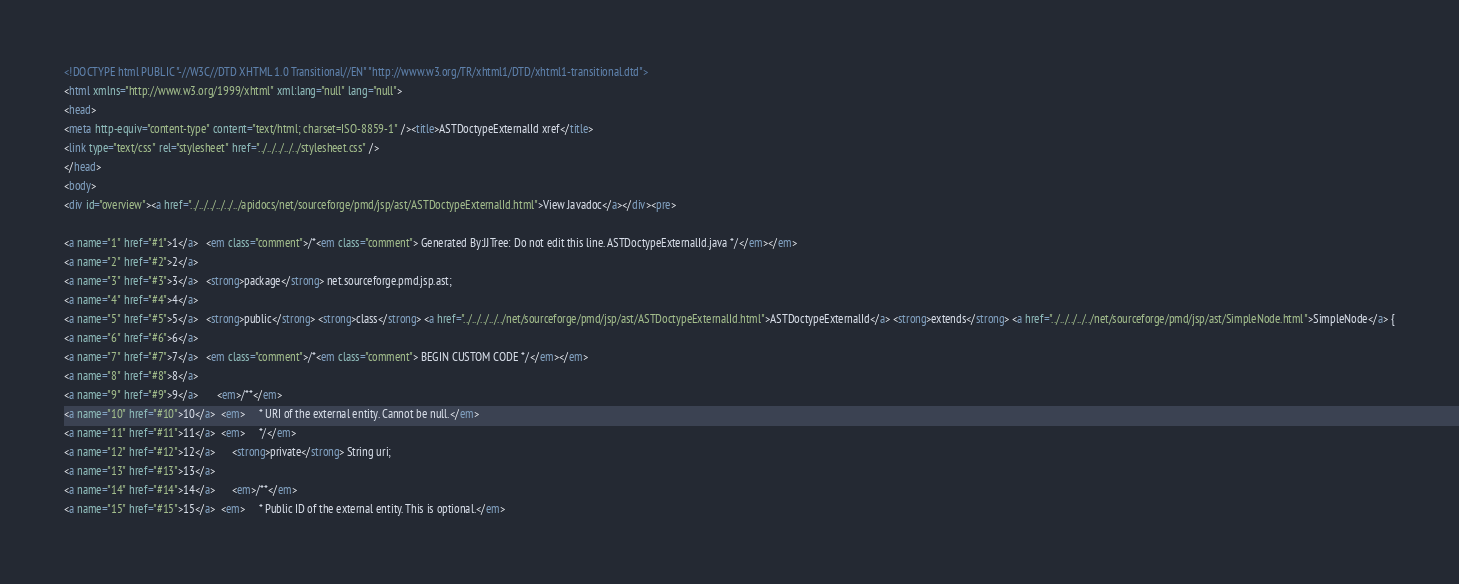<code> <loc_0><loc_0><loc_500><loc_500><_HTML_><!DOCTYPE html PUBLIC "-//W3C//DTD XHTML 1.0 Transitional//EN" "http://www.w3.org/TR/xhtml1/DTD/xhtml1-transitional.dtd">
<html xmlns="http://www.w3.org/1999/xhtml" xml:lang="null" lang="null">
<head>
<meta http-equiv="content-type" content="text/html; charset=ISO-8859-1" /><title>ASTDoctypeExternalId xref</title>
<link type="text/css" rel="stylesheet" href="../../../../../stylesheet.css" />
</head>
<body>
<div id="overview"><a href="../../../../../../apidocs/net/sourceforge/pmd/jsp/ast/ASTDoctypeExternalId.html">View Javadoc</a></div><pre>

<a name="1" href="#1">1</a>   <em class="comment">/*<em class="comment"> Generated By:JJTree: Do not edit this line. ASTDoctypeExternalId.java */</em></em>
<a name="2" href="#2">2</a>   
<a name="3" href="#3">3</a>   <strong>package</strong> net.sourceforge.pmd.jsp.ast;
<a name="4" href="#4">4</a>   
<a name="5" href="#5">5</a>   <strong>public</strong> <strong>class</strong> <a href="../../../../../net/sourceforge/pmd/jsp/ast/ASTDoctypeExternalId.html">ASTDoctypeExternalId</a> <strong>extends</strong> <a href="../../../../../net/sourceforge/pmd/jsp/ast/SimpleNode.html">SimpleNode</a> {
<a name="6" href="#6">6</a>   
<a name="7" href="#7">7</a>   <em class="comment">/*<em class="comment"> BEGIN CUSTOM CODE */</em></em>
<a name="8" href="#8">8</a>   
<a name="9" href="#9">9</a>       <em>/**</em>
<a name="10" href="#10">10</a>  <em>     * URI of the external entity. Cannot be null.</em>
<a name="11" href="#11">11</a>  <em>     */</em>
<a name="12" href="#12">12</a>      <strong>private</strong> String uri;
<a name="13" href="#13">13</a>  
<a name="14" href="#14">14</a>      <em>/**</em>
<a name="15" href="#15">15</a>  <em>     * Public ID of the external entity. This is optional.</em></code> 